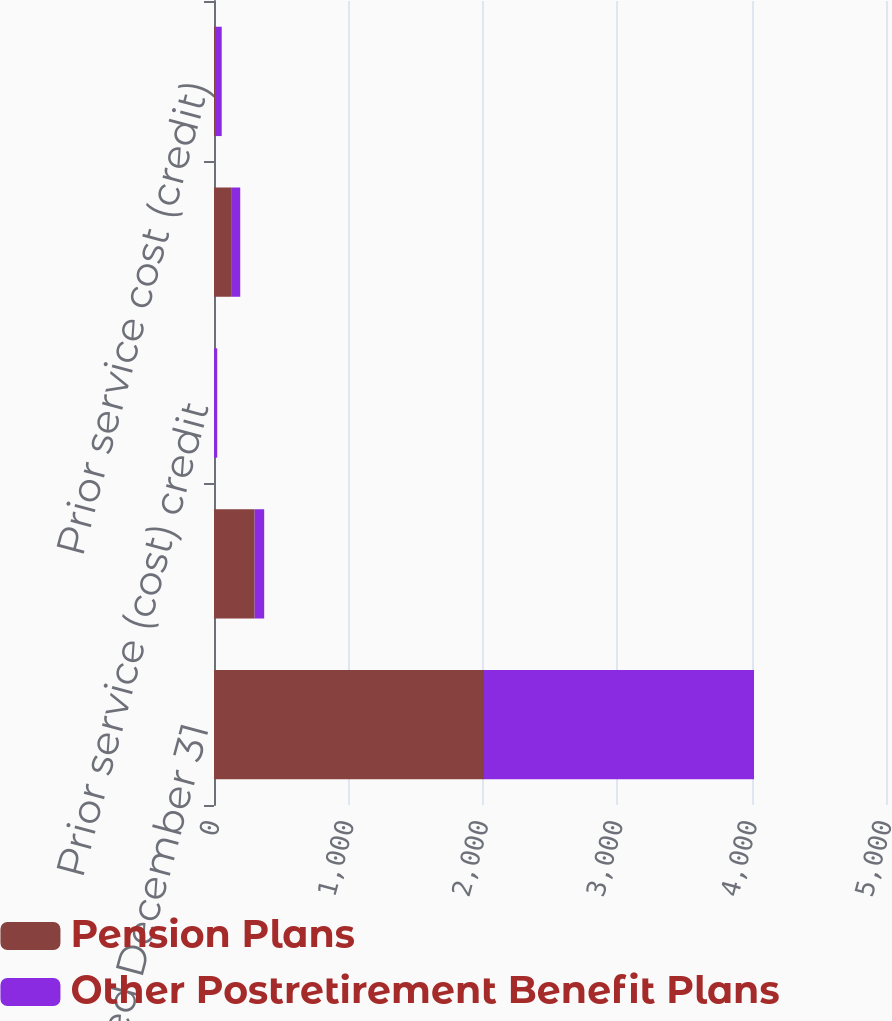Convert chart. <chart><loc_0><loc_0><loc_500><loc_500><stacked_bar_chart><ecel><fcel>Years Ended December 31<fcel>Net gain (loss) arising during<fcel>Prior service (cost) credit<fcel>Net loss amortization included<fcel>Prior service cost (credit)<nl><fcel>Pension Plans<fcel>2009<fcel>302.5<fcel>0.5<fcel>127.5<fcel>8.7<nl><fcel>Other Postretirement Benefit Plans<fcel>2009<fcel>70.9<fcel>23.5<fcel>67.7<fcel>48.8<nl></chart> 